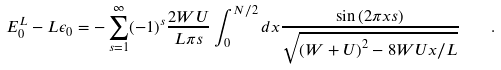Convert formula to latex. <formula><loc_0><loc_0><loc_500><loc_500>E _ { 0 } ^ { L } - L \epsilon _ { 0 } = - \sum _ { s = 1 } ^ { \infty } ( - 1 ) ^ { s } \frac { 2 W U } { L \pi s } \int _ { 0 } ^ { N / 2 } d x \frac { \sin \left ( 2 \pi x s \right ) } { \sqrt { \left ( W + U \right ) ^ { 2 } - 8 W U x / L } } \quad .</formula> 